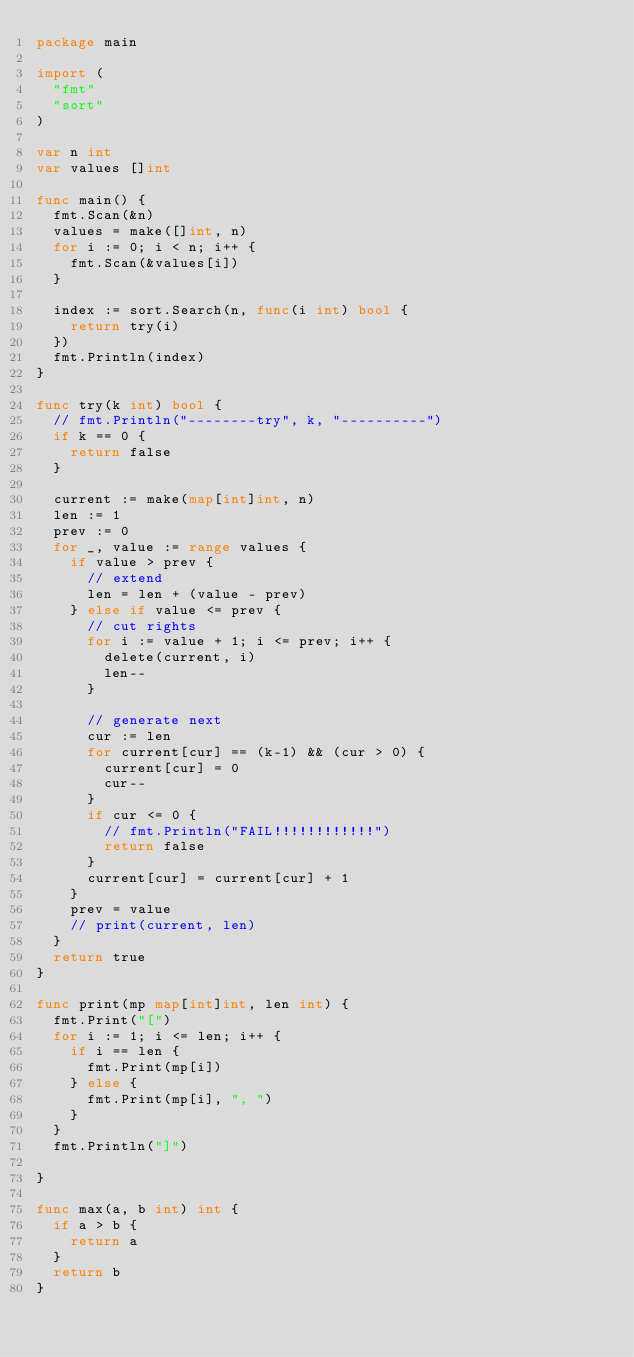Convert code to text. <code><loc_0><loc_0><loc_500><loc_500><_Go_>package main

import (
	"fmt"
	"sort"
)

var n int
var values []int

func main() {
	fmt.Scan(&n)
	values = make([]int, n)
	for i := 0; i < n; i++ {
		fmt.Scan(&values[i])
	}

	index := sort.Search(n, func(i int) bool {
		return try(i)
	})
	fmt.Println(index)
}

func try(k int) bool {
	// fmt.Println("--------try", k, "----------")
	if k == 0 {
		return false
	}

	current := make(map[int]int, n)
	len := 1
	prev := 0
	for _, value := range values {
		if value > prev {
			// extend
			len = len + (value - prev)
		} else if value <= prev {
			// cut rights
			for i := value + 1; i <= prev; i++ {
				delete(current, i)
				len--
			}

			// generate next
			cur := len
			for current[cur] == (k-1) && (cur > 0) {
				current[cur] = 0
				cur--
			}
			if cur <= 0 {
				// fmt.Println("FAIL!!!!!!!!!!!!")
				return false
			}
			current[cur] = current[cur] + 1
		}
		prev = value
		// print(current, len)
	}
	return true
}

func print(mp map[int]int, len int) {
	fmt.Print("[")
	for i := 1; i <= len; i++ {
		if i == len {
			fmt.Print(mp[i])
		} else {
			fmt.Print(mp[i], ", ")
		}
	}
	fmt.Println("]")

}

func max(a, b int) int {
	if a > b {
		return a
	}
	return b
}
</code> 